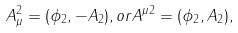<formula> <loc_0><loc_0><loc_500><loc_500>A _ { \mu } ^ { 2 } = ( \phi _ { 2 } , - A _ { 2 } ) , o r A ^ { \mu 2 } = ( \phi _ { 2 } , A _ { 2 } ) ,</formula> 